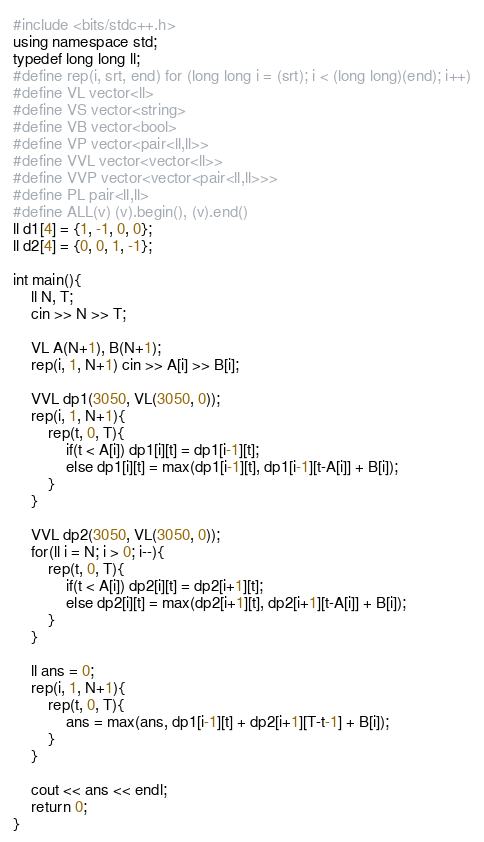<code> <loc_0><loc_0><loc_500><loc_500><_C++_>#include <bits/stdc++.h>
using namespace std;
typedef long long ll;
#define rep(i, srt, end) for (long long i = (srt); i < (long long)(end); i++)
#define VL vector<ll>
#define VS vector<string>
#define VB vector<bool>
#define VP vector<pair<ll,ll>>
#define VVL vector<vector<ll>>
#define VVP vector<vector<pair<ll,ll>>>
#define PL pair<ll,ll>
#define ALL(v) (v).begin(), (v).end()
ll d1[4] = {1, -1, 0, 0};
ll d2[4] = {0, 0, 1, -1};

int main(){
    ll N, T;
    cin >> N >> T;

    VL A(N+1), B(N+1);
    rep(i, 1, N+1) cin >> A[i] >> B[i];

    VVL dp1(3050, VL(3050, 0));
    rep(i, 1, N+1){
        rep(t, 0, T){
            if(t < A[i]) dp1[i][t] = dp1[i-1][t];
            else dp1[i][t] = max(dp1[i-1][t], dp1[i-1][t-A[i]] + B[i]);
        }
    }

    VVL dp2(3050, VL(3050, 0));
    for(ll i = N; i > 0; i--){
        rep(t, 0, T){
            if(t < A[i]) dp2[i][t] = dp2[i+1][t];
            else dp2[i][t] = max(dp2[i+1][t], dp2[i+1][t-A[i]] + B[i]);
        }
    }

    ll ans = 0;
    rep(i, 1, N+1){
        rep(t, 0, T){
            ans = max(ans, dp1[i-1][t] + dp2[i+1][T-t-1] + B[i]);
        }
    }

    cout << ans << endl;
    return 0;
}</code> 